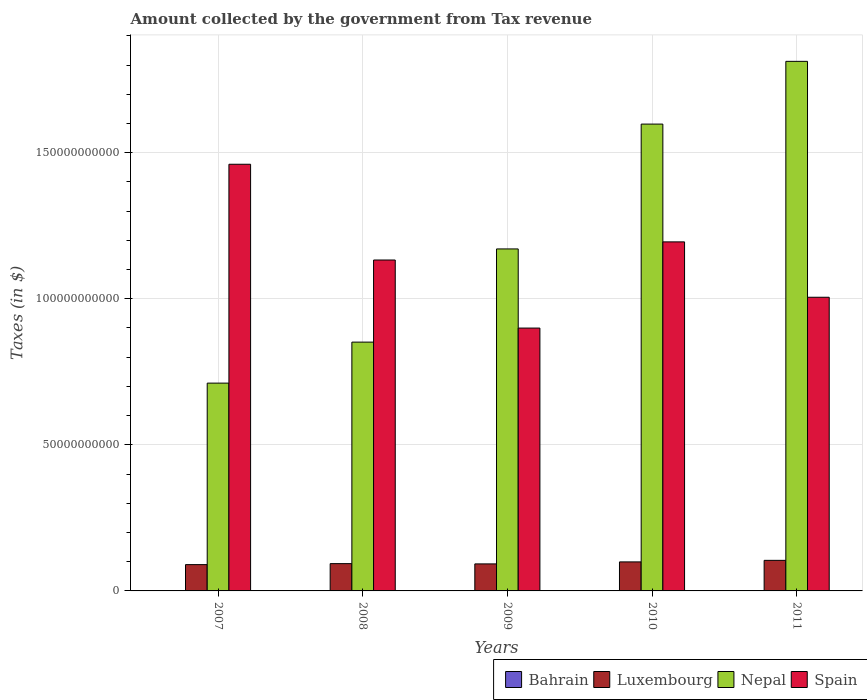How many different coloured bars are there?
Your answer should be compact. 4. Are the number of bars on each tick of the X-axis equal?
Your response must be concise. Yes. What is the label of the 3rd group of bars from the left?
Make the answer very short. 2009. What is the amount collected by the government from tax revenue in Spain in 2007?
Ensure brevity in your answer.  1.46e+11. Across all years, what is the maximum amount collected by the government from tax revenue in Nepal?
Your answer should be compact. 1.81e+11. Across all years, what is the minimum amount collected by the government from tax revenue in Luxembourg?
Your response must be concise. 9.00e+09. In which year was the amount collected by the government from tax revenue in Luxembourg maximum?
Provide a short and direct response. 2011. In which year was the amount collected by the government from tax revenue in Nepal minimum?
Provide a short and direct response. 2007. What is the total amount collected by the government from tax revenue in Luxembourg in the graph?
Make the answer very short. 4.80e+1. What is the difference between the amount collected by the government from tax revenue in Spain in 2010 and that in 2011?
Provide a short and direct response. 1.90e+1. What is the difference between the amount collected by the government from tax revenue in Nepal in 2011 and the amount collected by the government from tax revenue in Luxembourg in 2009?
Your answer should be compact. 1.72e+11. What is the average amount collected by the government from tax revenue in Nepal per year?
Your response must be concise. 1.23e+11. In the year 2008, what is the difference between the amount collected by the government from tax revenue in Bahrain and amount collected by the government from tax revenue in Spain?
Offer a terse response. -1.13e+11. In how many years, is the amount collected by the government from tax revenue in Nepal greater than 100000000000 $?
Provide a succinct answer. 3. What is the ratio of the amount collected by the government from tax revenue in Bahrain in 2007 to that in 2011?
Give a very brief answer. 0.78. Is the amount collected by the government from tax revenue in Bahrain in 2008 less than that in 2010?
Your answer should be compact. No. Is the difference between the amount collected by the government from tax revenue in Bahrain in 2007 and 2009 greater than the difference between the amount collected by the government from tax revenue in Spain in 2007 and 2009?
Offer a very short reply. No. What is the difference between the highest and the second highest amount collected by the government from tax revenue in Spain?
Ensure brevity in your answer.  2.66e+1. What is the difference between the highest and the lowest amount collected by the government from tax revenue in Spain?
Keep it short and to the point. 5.61e+1. In how many years, is the amount collected by the government from tax revenue in Nepal greater than the average amount collected by the government from tax revenue in Nepal taken over all years?
Your answer should be compact. 2. Is it the case that in every year, the sum of the amount collected by the government from tax revenue in Luxembourg and amount collected by the government from tax revenue in Bahrain is greater than the sum of amount collected by the government from tax revenue in Nepal and amount collected by the government from tax revenue in Spain?
Your answer should be very brief. No. What does the 2nd bar from the left in 2007 represents?
Give a very brief answer. Luxembourg. What does the 2nd bar from the right in 2010 represents?
Provide a short and direct response. Nepal. Is it the case that in every year, the sum of the amount collected by the government from tax revenue in Spain and amount collected by the government from tax revenue in Luxembourg is greater than the amount collected by the government from tax revenue in Bahrain?
Provide a succinct answer. Yes. How many bars are there?
Offer a terse response. 20. How many years are there in the graph?
Ensure brevity in your answer.  5. What is the difference between two consecutive major ticks on the Y-axis?
Give a very brief answer. 5.00e+1. Are the values on the major ticks of Y-axis written in scientific E-notation?
Your response must be concise. No. Does the graph contain grids?
Your response must be concise. Yes. Where does the legend appear in the graph?
Your answer should be compact. Bottom right. How are the legend labels stacked?
Make the answer very short. Horizontal. What is the title of the graph?
Your answer should be compact. Amount collected by the government from Tax revenue. Does "Uganda" appear as one of the legend labels in the graph?
Your answer should be very brief. No. What is the label or title of the X-axis?
Your answer should be very brief. Years. What is the label or title of the Y-axis?
Your answer should be compact. Taxes (in $). What is the Taxes (in $) in Bahrain in 2007?
Provide a succinct answer. 9.36e+07. What is the Taxes (in $) in Luxembourg in 2007?
Your response must be concise. 9.00e+09. What is the Taxes (in $) in Nepal in 2007?
Offer a terse response. 7.11e+1. What is the Taxes (in $) in Spain in 2007?
Ensure brevity in your answer.  1.46e+11. What is the Taxes (in $) of Bahrain in 2008?
Provide a succinct answer. 1.19e+08. What is the Taxes (in $) in Luxembourg in 2008?
Provide a succinct answer. 9.34e+09. What is the Taxes (in $) in Nepal in 2008?
Your answer should be compact. 8.52e+1. What is the Taxes (in $) in Spain in 2008?
Provide a short and direct response. 1.13e+11. What is the Taxes (in $) in Bahrain in 2009?
Provide a succinct answer. 1.18e+08. What is the Taxes (in $) in Luxembourg in 2009?
Provide a short and direct response. 9.25e+09. What is the Taxes (in $) in Nepal in 2009?
Your answer should be very brief. 1.17e+11. What is the Taxes (in $) of Spain in 2009?
Offer a very short reply. 9.00e+1. What is the Taxes (in $) in Bahrain in 2010?
Offer a very short reply. 1.14e+08. What is the Taxes (in $) in Luxembourg in 2010?
Keep it short and to the point. 9.93e+09. What is the Taxes (in $) of Nepal in 2010?
Give a very brief answer. 1.60e+11. What is the Taxes (in $) in Spain in 2010?
Provide a short and direct response. 1.19e+11. What is the Taxes (in $) of Bahrain in 2011?
Make the answer very short. 1.21e+08. What is the Taxes (in $) in Luxembourg in 2011?
Your answer should be very brief. 1.05e+1. What is the Taxes (in $) of Nepal in 2011?
Provide a succinct answer. 1.81e+11. What is the Taxes (in $) in Spain in 2011?
Provide a succinct answer. 1.01e+11. Across all years, what is the maximum Taxes (in $) of Bahrain?
Offer a very short reply. 1.21e+08. Across all years, what is the maximum Taxes (in $) in Luxembourg?
Keep it short and to the point. 1.05e+1. Across all years, what is the maximum Taxes (in $) of Nepal?
Your response must be concise. 1.81e+11. Across all years, what is the maximum Taxes (in $) of Spain?
Ensure brevity in your answer.  1.46e+11. Across all years, what is the minimum Taxes (in $) of Bahrain?
Offer a terse response. 9.36e+07. Across all years, what is the minimum Taxes (in $) of Luxembourg?
Provide a short and direct response. 9.00e+09. Across all years, what is the minimum Taxes (in $) of Nepal?
Ensure brevity in your answer.  7.11e+1. Across all years, what is the minimum Taxes (in $) in Spain?
Give a very brief answer. 9.00e+1. What is the total Taxes (in $) of Bahrain in the graph?
Provide a short and direct response. 5.65e+08. What is the total Taxes (in $) in Luxembourg in the graph?
Provide a short and direct response. 4.80e+1. What is the total Taxes (in $) of Nepal in the graph?
Keep it short and to the point. 6.14e+11. What is the total Taxes (in $) of Spain in the graph?
Make the answer very short. 5.69e+11. What is the difference between the Taxes (in $) in Bahrain in 2007 and that in 2008?
Make the answer very short. -2.59e+07. What is the difference between the Taxes (in $) in Luxembourg in 2007 and that in 2008?
Your answer should be compact. -3.40e+08. What is the difference between the Taxes (in $) of Nepal in 2007 and that in 2008?
Make the answer very short. -1.40e+1. What is the difference between the Taxes (in $) of Spain in 2007 and that in 2008?
Your answer should be compact. 3.28e+1. What is the difference between the Taxes (in $) in Bahrain in 2007 and that in 2009?
Ensure brevity in your answer.  -2.40e+07. What is the difference between the Taxes (in $) of Luxembourg in 2007 and that in 2009?
Your answer should be compact. -2.45e+08. What is the difference between the Taxes (in $) in Nepal in 2007 and that in 2009?
Your response must be concise. -4.59e+1. What is the difference between the Taxes (in $) in Spain in 2007 and that in 2009?
Give a very brief answer. 5.61e+1. What is the difference between the Taxes (in $) of Bahrain in 2007 and that in 2010?
Provide a succinct answer. -2.02e+07. What is the difference between the Taxes (in $) of Luxembourg in 2007 and that in 2010?
Provide a short and direct response. -9.30e+08. What is the difference between the Taxes (in $) in Nepal in 2007 and that in 2010?
Make the answer very short. -8.87e+1. What is the difference between the Taxes (in $) of Spain in 2007 and that in 2010?
Give a very brief answer. 2.66e+1. What is the difference between the Taxes (in $) in Bahrain in 2007 and that in 2011?
Provide a short and direct response. -2.70e+07. What is the difference between the Taxes (in $) of Luxembourg in 2007 and that in 2011?
Ensure brevity in your answer.  -1.46e+09. What is the difference between the Taxes (in $) in Nepal in 2007 and that in 2011?
Provide a short and direct response. -1.10e+11. What is the difference between the Taxes (in $) in Spain in 2007 and that in 2011?
Your response must be concise. 4.55e+1. What is the difference between the Taxes (in $) in Bahrain in 2008 and that in 2009?
Your answer should be compact. 1.90e+06. What is the difference between the Taxes (in $) in Luxembourg in 2008 and that in 2009?
Ensure brevity in your answer.  9.52e+07. What is the difference between the Taxes (in $) of Nepal in 2008 and that in 2009?
Your answer should be very brief. -3.19e+1. What is the difference between the Taxes (in $) in Spain in 2008 and that in 2009?
Your answer should be compact. 2.33e+1. What is the difference between the Taxes (in $) of Bahrain in 2008 and that in 2010?
Offer a terse response. 5.75e+06. What is the difference between the Taxes (in $) of Luxembourg in 2008 and that in 2010?
Give a very brief answer. -5.90e+08. What is the difference between the Taxes (in $) in Nepal in 2008 and that in 2010?
Offer a terse response. -7.46e+1. What is the difference between the Taxes (in $) of Spain in 2008 and that in 2010?
Your response must be concise. -6.20e+09. What is the difference between the Taxes (in $) in Bahrain in 2008 and that in 2011?
Make the answer very short. -1.08e+06. What is the difference between the Taxes (in $) of Luxembourg in 2008 and that in 2011?
Provide a short and direct response. -1.12e+09. What is the difference between the Taxes (in $) of Nepal in 2008 and that in 2011?
Offer a very short reply. -9.61e+1. What is the difference between the Taxes (in $) in Spain in 2008 and that in 2011?
Your answer should be compact. 1.28e+1. What is the difference between the Taxes (in $) in Bahrain in 2009 and that in 2010?
Make the answer very short. 3.85e+06. What is the difference between the Taxes (in $) in Luxembourg in 2009 and that in 2010?
Offer a very short reply. -6.85e+08. What is the difference between the Taxes (in $) in Nepal in 2009 and that in 2010?
Provide a succinct answer. -4.27e+1. What is the difference between the Taxes (in $) of Spain in 2009 and that in 2010?
Offer a very short reply. -2.95e+1. What is the difference between the Taxes (in $) in Bahrain in 2009 and that in 2011?
Provide a succinct answer. -2.98e+06. What is the difference between the Taxes (in $) in Luxembourg in 2009 and that in 2011?
Your answer should be compact. -1.22e+09. What is the difference between the Taxes (in $) of Nepal in 2009 and that in 2011?
Your response must be concise. -6.42e+1. What is the difference between the Taxes (in $) of Spain in 2009 and that in 2011?
Your response must be concise. -1.05e+1. What is the difference between the Taxes (in $) in Bahrain in 2010 and that in 2011?
Ensure brevity in your answer.  -6.83e+06. What is the difference between the Taxes (in $) of Luxembourg in 2010 and that in 2011?
Your answer should be very brief. -5.33e+08. What is the difference between the Taxes (in $) in Nepal in 2010 and that in 2011?
Give a very brief answer. -2.15e+1. What is the difference between the Taxes (in $) in Spain in 2010 and that in 2011?
Offer a very short reply. 1.90e+1. What is the difference between the Taxes (in $) of Bahrain in 2007 and the Taxes (in $) of Luxembourg in 2008?
Give a very brief answer. -9.25e+09. What is the difference between the Taxes (in $) in Bahrain in 2007 and the Taxes (in $) in Nepal in 2008?
Provide a succinct answer. -8.51e+1. What is the difference between the Taxes (in $) in Bahrain in 2007 and the Taxes (in $) in Spain in 2008?
Your answer should be compact. -1.13e+11. What is the difference between the Taxes (in $) of Luxembourg in 2007 and the Taxes (in $) of Nepal in 2008?
Give a very brief answer. -7.62e+1. What is the difference between the Taxes (in $) of Luxembourg in 2007 and the Taxes (in $) of Spain in 2008?
Keep it short and to the point. -1.04e+11. What is the difference between the Taxes (in $) of Nepal in 2007 and the Taxes (in $) of Spain in 2008?
Make the answer very short. -4.21e+1. What is the difference between the Taxes (in $) in Bahrain in 2007 and the Taxes (in $) in Luxembourg in 2009?
Your response must be concise. -9.15e+09. What is the difference between the Taxes (in $) of Bahrain in 2007 and the Taxes (in $) of Nepal in 2009?
Your response must be concise. -1.17e+11. What is the difference between the Taxes (in $) in Bahrain in 2007 and the Taxes (in $) in Spain in 2009?
Make the answer very short. -8.99e+1. What is the difference between the Taxes (in $) of Luxembourg in 2007 and the Taxes (in $) of Nepal in 2009?
Your response must be concise. -1.08e+11. What is the difference between the Taxes (in $) in Luxembourg in 2007 and the Taxes (in $) in Spain in 2009?
Give a very brief answer. -8.10e+1. What is the difference between the Taxes (in $) in Nepal in 2007 and the Taxes (in $) in Spain in 2009?
Keep it short and to the point. -1.88e+1. What is the difference between the Taxes (in $) in Bahrain in 2007 and the Taxes (in $) in Luxembourg in 2010?
Your answer should be compact. -9.84e+09. What is the difference between the Taxes (in $) of Bahrain in 2007 and the Taxes (in $) of Nepal in 2010?
Keep it short and to the point. -1.60e+11. What is the difference between the Taxes (in $) in Bahrain in 2007 and the Taxes (in $) in Spain in 2010?
Ensure brevity in your answer.  -1.19e+11. What is the difference between the Taxes (in $) in Luxembourg in 2007 and the Taxes (in $) in Nepal in 2010?
Your answer should be compact. -1.51e+11. What is the difference between the Taxes (in $) in Luxembourg in 2007 and the Taxes (in $) in Spain in 2010?
Provide a succinct answer. -1.10e+11. What is the difference between the Taxes (in $) of Nepal in 2007 and the Taxes (in $) of Spain in 2010?
Your answer should be compact. -4.83e+1. What is the difference between the Taxes (in $) in Bahrain in 2007 and the Taxes (in $) in Luxembourg in 2011?
Provide a short and direct response. -1.04e+1. What is the difference between the Taxes (in $) in Bahrain in 2007 and the Taxes (in $) in Nepal in 2011?
Make the answer very short. -1.81e+11. What is the difference between the Taxes (in $) in Bahrain in 2007 and the Taxes (in $) in Spain in 2011?
Keep it short and to the point. -1.00e+11. What is the difference between the Taxes (in $) in Luxembourg in 2007 and the Taxes (in $) in Nepal in 2011?
Provide a succinct answer. -1.72e+11. What is the difference between the Taxes (in $) of Luxembourg in 2007 and the Taxes (in $) of Spain in 2011?
Keep it short and to the point. -9.15e+1. What is the difference between the Taxes (in $) of Nepal in 2007 and the Taxes (in $) of Spain in 2011?
Provide a succinct answer. -2.94e+1. What is the difference between the Taxes (in $) in Bahrain in 2008 and the Taxes (in $) in Luxembourg in 2009?
Your answer should be compact. -9.13e+09. What is the difference between the Taxes (in $) in Bahrain in 2008 and the Taxes (in $) in Nepal in 2009?
Give a very brief answer. -1.17e+11. What is the difference between the Taxes (in $) of Bahrain in 2008 and the Taxes (in $) of Spain in 2009?
Your answer should be very brief. -8.98e+1. What is the difference between the Taxes (in $) of Luxembourg in 2008 and the Taxes (in $) of Nepal in 2009?
Provide a short and direct response. -1.08e+11. What is the difference between the Taxes (in $) in Luxembourg in 2008 and the Taxes (in $) in Spain in 2009?
Offer a terse response. -8.06e+1. What is the difference between the Taxes (in $) in Nepal in 2008 and the Taxes (in $) in Spain in 2009?
Keep it short and to the point. -4.81e+09. What is the difference between the Taxes (in $) of Bahrain in 2008 and the Taxes (in $) of Luxembourg in 2010?
Your response must be concise. -9.81e+09. What is the difference between the Taxes (in $) in Bahrain in 2008 and the Taxes (in $) in Nepal in 2010?
Make the answer very short. -1.60e+11. What is the difference between the Taxes (in $) in Bahrain in 2008 and the Taxes (in $) in Spain in 2010?
Keep it short and to the point. -1.19e+11. What is the difference between the Taxes (in $) of Luxembourg in 2008 and the Taxes (in $) of Nepal in 2010?
Your answer should be compact. -1.50e+11. What is the difference between the Taxes (in $) in Luxembourg in 2008 and the Taxes (in $) in Spain in 2010?
Provide a succinct answer. -1.10e+11. What is the difference between the Taxes (in $) in Nepal in 2008 and the Taxes (in $) in Spain in 2010?
Provide a short and direct response. -3.43e+1. What is the difference between the Taxes (in $) in Bahrain in 2008 and the Taxes (in $) in Luxembourg in 2011?
Provide a short and direct response. -1.03e+1. What is the difference between the Taxes (in $) of Bahrain in 2008 and the Taxes (in $) of Nepal in 2011?
Your answer should be very brief. -1.81e+11. What is the difference between the Taxes (in $) in Bahrain in 2008 and the Taxes (in $) in Spain in 2011?
Keep it short and to the point. -1.00e+11. What is the difference between the Taxes (in $) in Luxembourg in 2008 and the Taxes (in $) in Nepal in 2011?
Your answer should be very brief. -1.72e+11. What is the difference between the Taxes (in $) of Luxembourg in 2008 and the Taxes (in $) of Spain in 2011?
Your answer should be compact. -9.12e+1. What is the difference between the Taxes (in $) of Nepal in 2008 and the Taxes (in $) of Spain in 2011?
Offer a very short reply. -1.54e+1. What is the difference between the Taxes (in $) in Bahrain in 2009 and the Taxes (in $) in Luxembourg in 2010?
Your response must be concise. -9.81e+09. What is the difference between the Taxes (in $) in Bahrain in 2009 and the Taxes (in $) in Nepal in 2010?
Make the answer very short. -1.60e+11. What is the difference between the Taxes (in $) of Bahrain in 2009 and the Taxes (in $) of Spain in 2010?
Offer a terse response. -1.19e+11. What is the difference between the Taxes (in $) of Luxembourg in 2009 and the Taxes (in $) of Nepal in 2010?
Your response must be concise. -1.51e+11. What is the difference between the Taxes (in $) in Luxembourg in 2009 and the Taxes (in $) in Spain in 2010?
Provide a short and direct response. -1.10e+11. What is the difference between the Taxes (in $) of Nepal in 2009 and the Taxes (in $) of Spain in 2010?
Your response must be concise. -2.42e+09. What is the difference between the Taxes (in $) of Bahrain in 2009 and the Taxes (in $) of Luxembourg in 2011?
Offer a very short reply. -1.03e+1. What is the difference between the Taxes (in $) in Bahrain in 2009 and the Taxes (in $) in Nepal in 2011?
Your response must be concise. -1.81e+11. What is the difference between the Taxes (in $) in Bahrain in 2009 and the Taxes (in $) in Spain in 2011?
Keep it short and to the point. -1.00e+11. What is the difference between the Taxes (in $) of Luxembourg in 2009 and the Taxes (in $) of Nepal in 2011?
Keep it short and to the point. -1.72e+11. What is the difference between the Taxes (in $) in Luxembourg in 2009 and the Taxes (in $) in Spain in 2011?
Give a very brief answer. -9.13e+1. What is the difference between the Taxes (in $) of Nepal in 2009 and the Taxes (in $) of Spain in 2011?
Your response must be concise. 1.65e+1. What is the difference between the Taxes (in $) of Bahrain in 2010 and the Taxes (in $) of Luxembourg in 2011?
Keep it short and to the point. -1.04e+1. What is the difference between the Taxes (in $) in Bahrain in 2010 and the Taxes (in $) in Nepal in 2011?
Keep it short and to the point. -1.81e+11. What is the difference between the Taxes (in $) of Bahrain in 2010 and the Taxes (in $) of Spain in 2011?
Your answer should be very brief. -1.00e+11. What is the difference between the Taxes (in $) of Luxembourg in 2010 and the Taxes (in $) of Nepal in 2011?
Give a very brief answer. -1.71e+11. What is the difference between the Taxes (in $) of Luxembourg in 2010 and the Taxes (in $) of Spain in 2011?
Offer a terse response. -9.06e+1. What is the difference between the Taxes (in $) in Nepal in 2010 and the Taxes (in $) in Spain in 2011?
Your response must be concise. 5.93e+1. What is the average Taxes (in $) in Bahrain per year?
Your answer should be compact. 1.13e+08. What is the average Taxes (in $) in Luxembourg per year?
Provide a short and direct response. 9.60e+09. What is the average Taxes (in $) of Nepal per year?
Make the answer very short. 1.23e+11. What is the average Taxes (in $) of Spain per year?
Your answer should be compact. 1.14e+11. In the year 2007, what is the difference between the Taxes (in $) of Bahrain and Taxes (in $) of Luxembourg?
Offer a very short reply. -8.91e+09. In the year 2007, what is the difference between the Taxes (in $) in Bahrain and Taxes (in $) in Nepal?
Keep it short and to the point. -7.10e+1. In the year 2007, what is the difference between the Taxes (in $) in Bahrain and Taxes (in $) in Spain?
Your response must be concise. -1.46e+11. In the year 2007, what is the difference between the Taxes (in $) in Luxembourg and Taxes (in $) in Nepal?
Provide a succinct answer. -6.21e+1. In the year 2007, what is the difference between the Taxes (in $) in Luxembourg and Taxes (in $) in Spain?
Make the answer very short. -1.37e+11. In the year 2007, what is the difference between the Taxes (in $) in Nepal and Taxes (in $) in Spain?
Give a very brief answer. -7.49e+1. In the year 2008, what is the difference between the Taxes (in $) in Bahrain and Taxes (in $) in Luxembourg?
Keep it short and to the point. -9.22e+09. In the year 2008, what is the difference between the Taxes (in $) of Bahrain and Taxes (in $) of Nepal?
Offer a very short reply. -8.50e+1. In the year 2008, what is the difference between the Taxes (in $) in Bahrain and Taxes (in $) in Spain?
Your answer should be very brief. -1.13e+11. In the year 2008, what is the difference between the Taxes (in $) of Luxembourg and Taxes (in $) of Nepal?
Offer a very short reply. -7.58e+1. In the year 2008, what is the difference between the Taxes (in $) in Luxembourg and Taxes (in $) in Spain?
Provide a succinct answer. -1.04e+11. In the year 2008, what is the difference between the Taxes (in $) in Nepal and Taxes (in $) in Spain?
Provide a short and direct response. -2.81e+1. In the year 2009, what is the difference between the Taxes (in $) in Bahrain and Taxes (in $) in Luxembourg?
Make the answer very short. -9.13e+09. In the year 2009, what is the difference between the Taxes (in $) of Bahrain and Taxes (in $) of Nepal?
Make the answer very short. -1.17e+11. In the year 2009, what is the difference between the Taxes (in $) in Bahrain and Taxes (in $) in Spain?
Provide a short and direct response. -8.98e+1. In the year 2009, what is the difference between the Taxes (in $) of Luxembourg and Taxes (in $) of Nepal?
Your answer should be compact. -1.08e+11. In the year 2009, what is the difference between the Taxes (in $) in Luxembourg and Taxes (in $) in Spain?
Give a very brief answer. -8.07e+1. In the year 2009, what is the difference between the Taxes (in $) in Nepal and Taxes (in $) in Spain?
Your response must be concise. 2.71e+1. In the year 2010, what is the difference between the Taxes (in $) of Bahrain and Taxes (in $) of Luxembourg?
Your answer should be very brief. -9.82e+09. In the year 2010, what is the difference between the Taxes (in $) of Bahrain and Taxes (in $) of Nepal?
Your answer should be very brief. -1.60e+11. In the year 2010, what is the difference between the Taxes (in $) of Bahrain and Taxes (in $) of Spain?
Give a very brief answer. -1.19e+11. In the year 2010, what is the difference between the Taxes (in $) in Luxembourg and Taxes (in $) in Nepal?
Your answer should be compact. -1.50e+11. In the year 2010, what is the difference between the Taxes (in $) of Luxembourg and Taxes (in $) of Spain?
Offer a very short reply. -1.10e+11. In the year 2010, what is the difference between the Taxes (in $) in Nepal and Taxes (in $) in Spain?
Keep it short and to the point. 4.03e+1. In the year 2011, what is the difference between the Taxes (in $) of Bahrain and Taxes (in $) of Luxembourg?
Your answer should be compact. -1.03e+1. In the year 2011, what is the difference between the Taxes (in $) in Bahrain and Taxes (in $) in Nepal?
Keep it short and to the point. -1.81e+11. In the year 2011, what is the difference between the Taxes (in $) in Bahrain and Taxes (in $) in Spain?
Provide a succinct answer. -1.00e+11. In the year 2011, what is the difference between the Taxes (in $) of Luxembourg and Taxes (in $) of Nepal?
Your answer should be compact. -1.71e+11. In the year 2011, what is the difference between the Taxes (in $) in Luxembourg and Taxes (in $) in Spain?
Your response must be concise. -9.00e+1. In the year 2011, what is the difference between the Taxes (in $) in Nepal and Taxes (in $) in Spain?
Give a very brief answer. 8.07e+1. What is the ratio of the Taxes (in $) in Bahrain in 2007 to that in 2008?
Your answer should be compact. 0.78. What is the ratio of the Taxes (in $) in Luxembourg in 2007 to that in 2008?
Provide a short and direct response. 0.96. What is the ratio of the Taxes (in $) of Nepal in 2007 to that in 2008?
Offer a very short reply. 0.84. What is the ratio of the Taxes (in $) of Spain in 2007 to that in 2008?
Keep it short and to the point. 1.29. What is the ratio of the Taxes (in $) in Bahrain in 2007 to that in 2009?
Keep it short and to the point. 0.8. What is the ratio of the Taxes (in $) in Luxembourg in 2007 to that in 2009?
Give a very brief answer. 0.97. What is the ratio of the Taxes (in $) in Nepal in 2007 to that in 2009?
Offer a very short reply. 0.61. What is the ratio of the Taxes (in $) of Spain in 2007 to that in 2009?
Your answer should be compact. 1.62. What is the ratio of the Taxes (in $) in Bahrain in 2007 to that in 2010?
Your answer should be very brief. 0.82. What is the ratio of the Taxes (in $) in Luxembourg in 2007 to that in 2010?
Provide a short and direct response. 0.91. What is the ratio of the Taxes (in $) in Nepal in 2007 to that in 2010?
Ensure brevity in your answer.  0.45. What is the ratio of the Taxes (in $) of Spain in 2007 to that in 2010?
Your response must be concise. 1.22. What is the ratio of the Taxes (in $) in Bahrain in 2007 to that in 2011?
Offer a terse response. 0.78. What is the ratio of the Taxes (in $) in Luxembourg in 2007 to that in 2011?
Offer a very short reply. 0.86. What is the ratio of the Taxes (in $) of Nepal in 2007 to that in 2011?
Your response must be concise. 0.39. What is the ratio of the Taxes (in $) of Spain in 2007 to that in 2011?
Offer a terse response. 1.45. What is the ratio of the Taxes (in $) in Bahrain in 2008 to that in 2009?
Make the answer very short. 1.02. What is the ratio of the Taxes (in $) in Luxembourg in 2008 to that in 2009?
Keep it short and to the point. 1.01. What is the ratio of the Taxes (in $) in Nepal in 2008 to that in 2009?
Make the answer very short. 0.73. What is the ratio of the Taxes (in $) in Spain in 2008 to that in 2009?
Keep it short and to the point. 1.26. What is the ratio of the Taxes (in $) of Bahrain in 2008 to that in 2010?
Provide a short and direct response. 1.05. What is the ratio of the Taxes (in $) in Luxembourg in 2008 to that in 2010?
Your answer should be compact. 0.94. What is the ratio of the Taxes (in $) in Nepal in 2008 to that in 2010?
Ensure brevity in your answer.  0.53. What is the ratio of the Taxes (in $) in Spain in 2008 to that in 2010?
Your answer should be compact. 0.95. What is the ratio of the Taxes (in $) of Bahrain in 2008 to that in 2011?
Give a very brief answer. 0.99. What is the ratio of the Taxes (in $) in Luxembourg in 2008 to that in 2011?
Ensure brevity in your answer.  0.89. What is the ratio of the Taxes (in $) in Nepal in 2008 to that in 2011?
Provide a short and direct response. 0.47. What is the ratio of the Taxes (in $) in Spain in 2008 to that in 2011?
Your response must be concise. 1.13. What is the ratio of the Taxes (in $) of Bahrain in 2009 to that in 2010?
Offer a very short reply. 1.03. What is the ratio of the Taxes (in $) in Luxembourg in 2009 to that in 2010?
Provide a succinct answer. 0.93. What is the ratio of the Taxes (in $) of Nepal in 2009 to that in 2010?
Make the answer very short. 0.73. What is the ratio of the Taxes (in $) in Spain in 2009 to that in 2010?
Offer a very short reply. 0.75. What is the ratio of the Taxes (in $) in Bahrain in 2009 to that in 2011?
Provide a short and direct response. 0.98. What is the ratio of the Taxes (in $) of Luxembourg in 2009 to that in 2011?
Your answer should be compact. 0.88. What is the ratio of the Taxes (in $) in Nepal in 2009 to that in 2011?
Offer a terse response. 0.65. What is the ratio of the Taxes (in $) of Spain in 2009 to that in 2011?
Provide a succinct answer. 0.9. What is the ratio of the Taxes (in $) of Bahrain in 2010 to that in 2011?
Your response must be concise. 0.94. What is the ratio of the Taxes (in $) in Luxembourg in 2010 to that in 2011?
Your answer should be very brief. 0.95. What is the ratio of the Taxes (in $) of Nepal in 2010 to that in 2011?
Keep it short and to the point. 0.88. What is the ratio of the Taxes (in $) in Spain in 2010 to that in 2011?
Your answer should be compact. 1.19. What is the difference between the highest and the second highest Taxes (in $) in Bahrain?
Your response must be concise. 1.08e+06. What is the difference between the highest and the second highest Taxes (in $) in Luxembourg?
Your answer should be compact. 5.33e+08. What is the difference between the highest and the second highest Taxes (in $) of Nepal?
Make the answer very short. 2.15e+1. What is the difference between the highest and the second highest Taxes (in $) of Spain?
Your answer should be very brief. 2.66e+1. What is the difference between the highest and the lowest Taxes (in $) of Bahrain?
Provide a short and direct response. 2.70e+07. What is the difference between the highest and the lowest Taxes (in $) in Luxembourg?
Keep it short and to the point. 1.46e+09. What is the difference between the highest and the lowest Taxes (in $) of Nepal?
Give a very brief answer. 1.10e+11. What is the difference between the highest and the lowest Taxes (in $) of Spain?
Your response must be concise. 5.61e+1. 